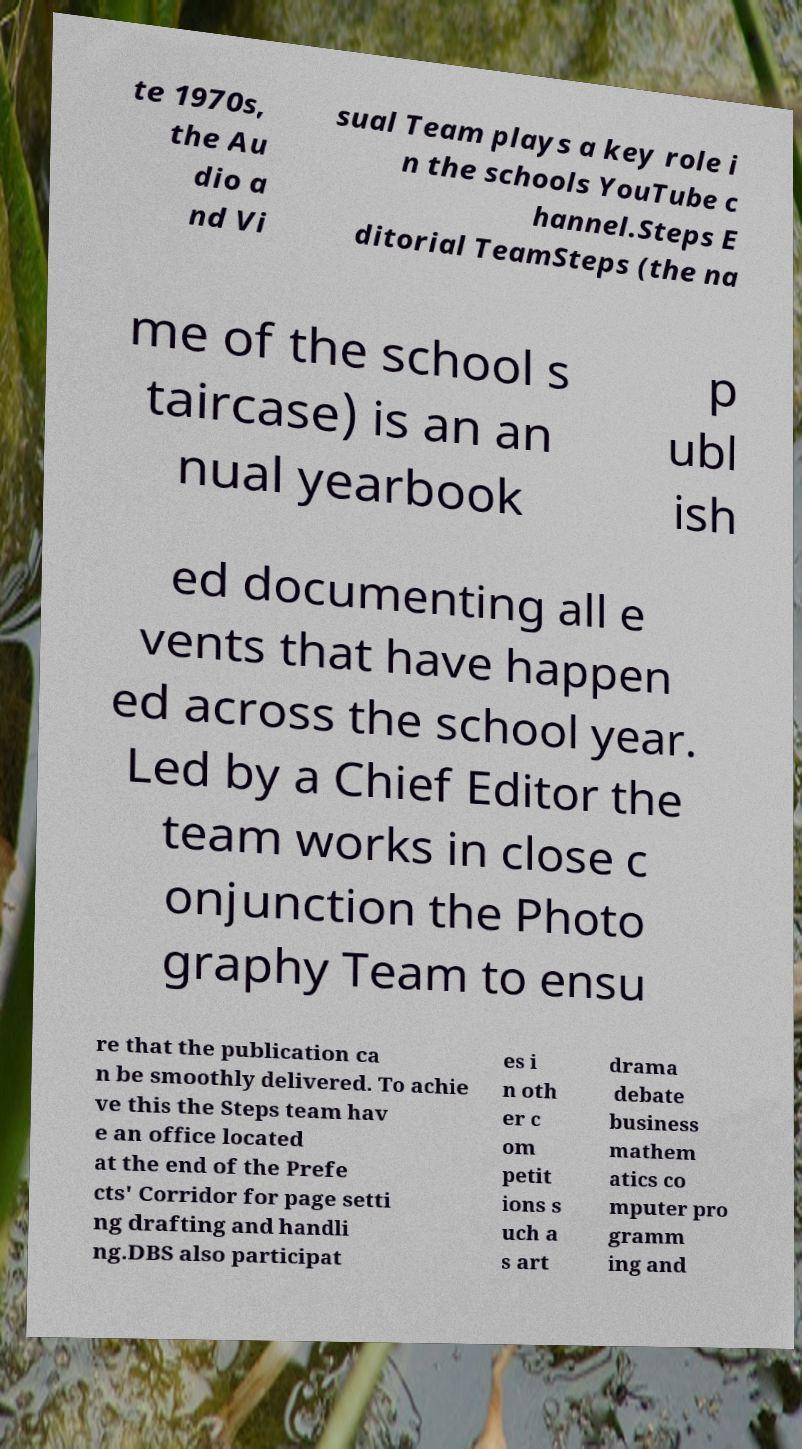Could you extract and type out the text from this image? te 1970s, the Au dio a nd Vi sual Team plays a key role i n the schools YouTube c hannel.Steps E ditorial TeamSteps (the na me of the school s taircase) is an an nual yearbook p ubl ish ed documenting all e vents that have happen ed across the school year. Led by a Chief Editor the team works in close c onjunction the Photo graphy Team to ensu re that the publication ca n be smoothly delivered. To achie ve this the Steps team hav e an office located at the end of the Prefe cts' Corridor for page setti ng drafting and handli ng.DBS also participat es i n oth er c om petit ions s uch a s art drama debate business mathem atics co mputer pro gramm ing and 